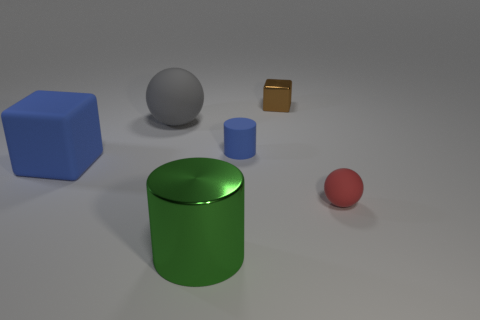Subtract all gray balls. How many balls are left? 1 Add 3 big red metal balls. How many objects exist? 9 Subtract 2 cubes. How many cubes are left? 0 Add 2 small matte spheres. How many small matte spheres exist? 3 Subtract 0 red blocks. How many objects are left? 6 Subtract all purple cylinders. Subtract all gray cubes. How many cylinders are left? 2 Subtract all small blue things. Subtract all blue things. How many objects are left? 3 Add 1 large gray balls. How many large gray balls are left? 2 